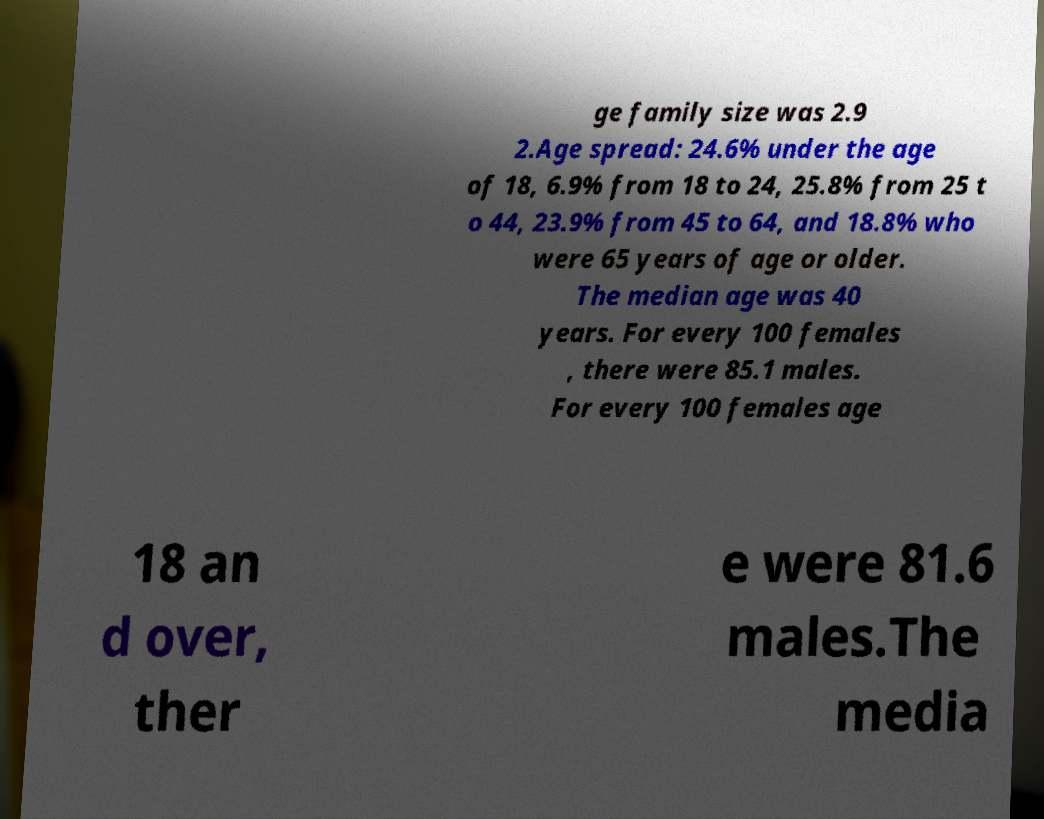There's text embedded in this image that I need extracted. Can you transcribe it verbatim? ge family size was 2.9 2.Age spread: 24.6% under the age of 18, 6.9% from 18 to 24, 25.8% from 25 t o 44, 23.9% from 45 to 64, and 18.8% who were 65 years of age or older. The median age was 40 years. For every 100 females , there were 85.1 males. For every 100 females age 18 an d over, ther e were 81.6 males.The media 